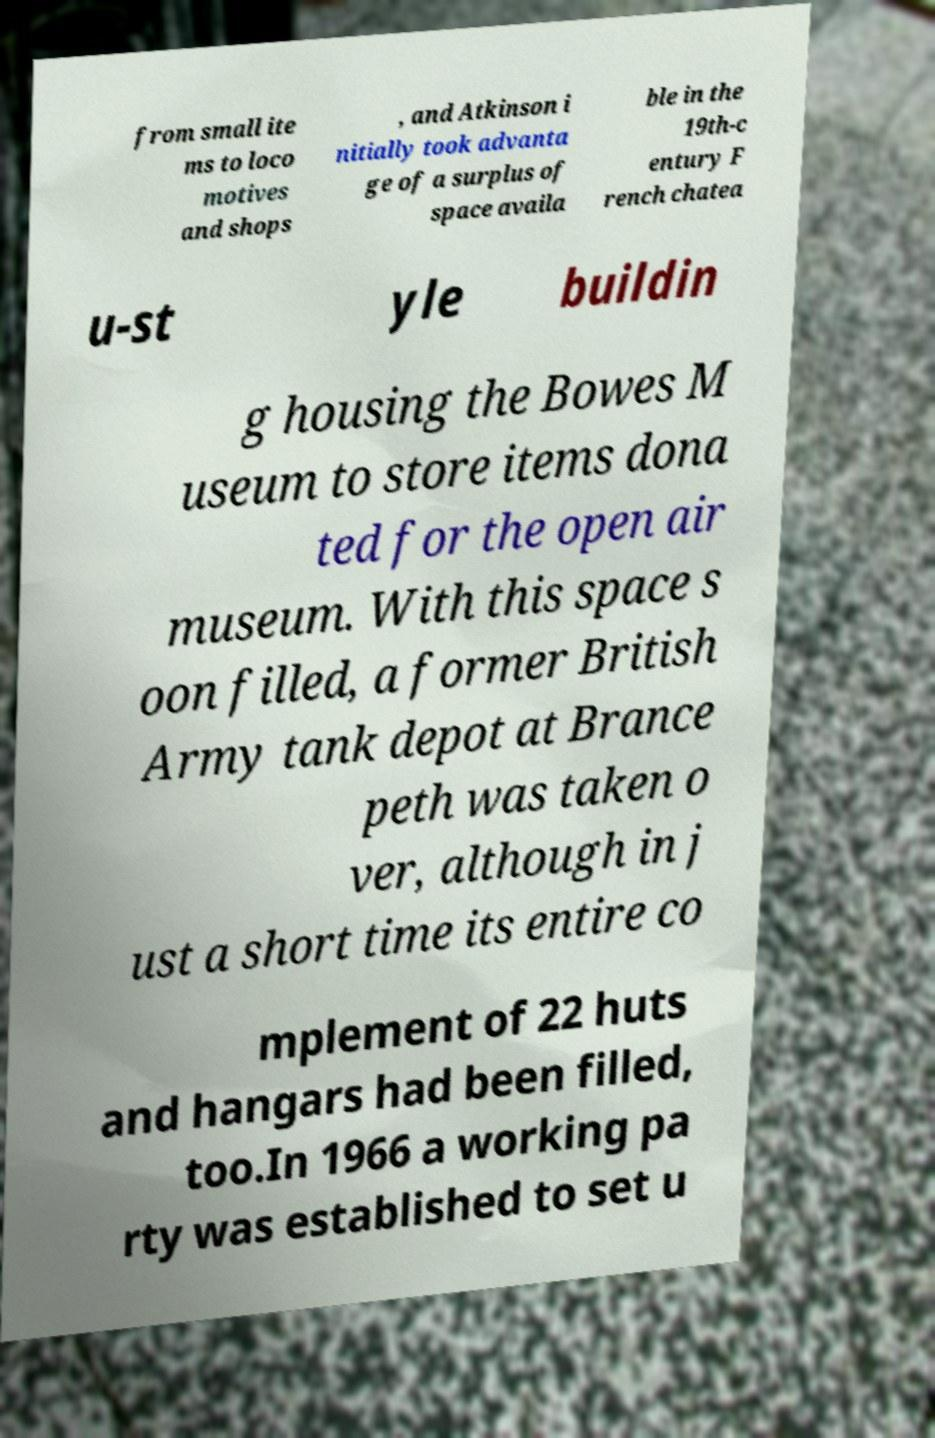Can you read and provide the text displayed in the image?This photo seems to have some interesting text. Can you extract and type it out for me? from small ite ms to loco motives and shops , and Atkinson i nitially took advanta ge of a surplus of space availa ble in the 19th-c entury F rench chatea u-st yle buildin g housing the Bowes M useum to store items dona ted for the open air museum. With this space s oon filled, a former British Army tank depot at Brance peth was taken o ver, although in j ust a short time its entire co mplement of 22 huts and hangars had been filled, too.In 1966 a working pa rty was established to set u 